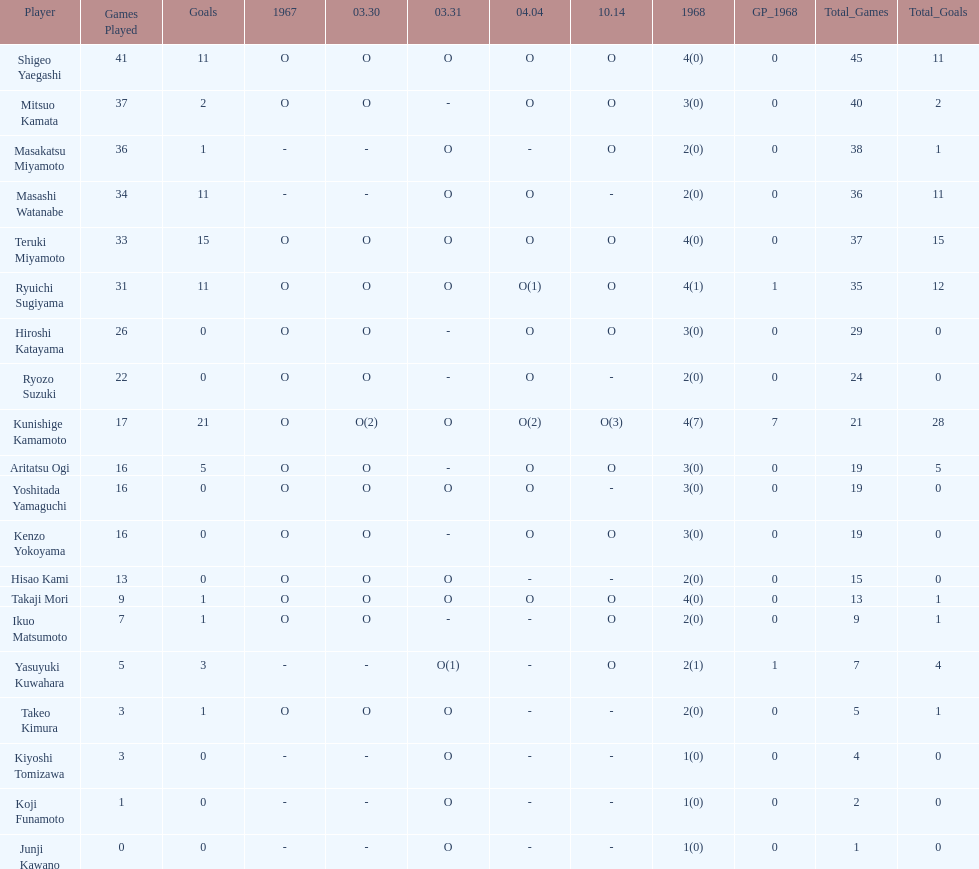How many total did mitsuo kamata have? 40(2). Parse the table in full. {'header': ['Player', 'Games Played', 'Goals', '1967', '03.30', '03.31', '04.04', '10.14', '1968', 'GP_1968', 'Total_Games', 'Total_Goals'], 'rows': [['Shigeo Yaegashi', '41', '11', 'O', 'O', 'O', 'O', 'O', '4(0)', '0', '45', '11'], ['Mitsuo Kamata', '37', '2', 'O', 'O', '-', 'O', 'O', '3(0)', '0', '40', '2'], ['Masakatsu Miyamoto', '36', '1', '-', '-', 'O', '-', 'O', '2(0)', '0', '38', '1'], ['Masashi Watanabe', '34', '11', '-', '-', 'O', 'O', '-', '2(0)', '0', '36', '11'], ['Teruki Miyamoto', '33', '15', 'O', 'O', 'O', 'O', 'O', '4(0)', '0', '37', '15'], ['Ryuichi Sugiyama', '31', '11', 'O', 'O', 'O', 'O(1)', 'O', '4(1)', '1', '35', '12'], ['Hiroshi Katayama', '26', '0', 'O', 'O', '-', 'O', 'O', '3(0)', '0', '29', '0'], ['Ryozo Suzuki', '22', '0', 'O', 'O', '-', 'O', '-', '2(0)', '0', '24', '0'], ['Kunishige Kamamoto', '17', '21', 'O', 'O(2)', 'O', 'O(2)', 'O(3)', '4(7)', '7', '21', '28'], ['Aritatsu Ogi', '16', '5', 'O', 'O', '-', 'O', 'O', '3(0)', '0', '19', '5'], ['Yoshitada Yamaguchi', '16', '0', 'O', 'O', 'O', 'O', '-', '3(0)', '0', '19', '0'], ['Kenzo Yokoyama', '16', '0', 'O', 'O', '-', 'O', 'O', '3(0)', '0', '19', '0'], ['Hisao Kami', '13', '0', 'O', 'O', 'O', '-', '-', '2(0)', '0', '15', '0'], ['Takaji Mori', '9', '1', 'O', 'O', 'O', 'O', 'O', '4(0)', '0', '13', '1'], ['Ikuo Matsumoto', '7', '1', 'O', 'O', '-', '-', 'O', '2(0)', '0', '9', '1'], ['Yasuyuki Kuwahara', '5', '3', '-', '-', 'O(1)', '-', 'O', '2(1)', '1', '7', '4'], ['Takeo Kimura', '3', '1', 'O', 'O', 'O', '-', '-', '2(0)', '0', '5', '1'], ['Kiyoshi Tomizawa', '3', '0', '-', '-', 'O', '-', '-', '1(0)', '0', '4', '0'], ['Koji Funamoto', '1', '0', '-', '-', 'O', '-', '-', '1(0)', '0', '2', '0'], ['Junji Kawano', '0', '0', '-', '-', 'O', '-', '-', '1(0)', '0', '1', '0']]} 